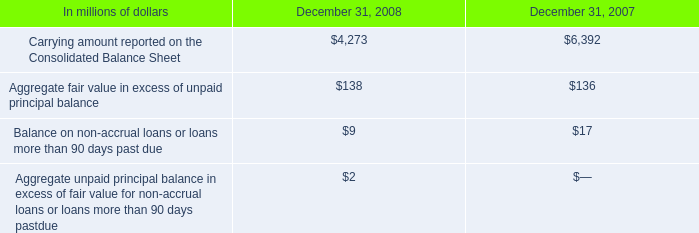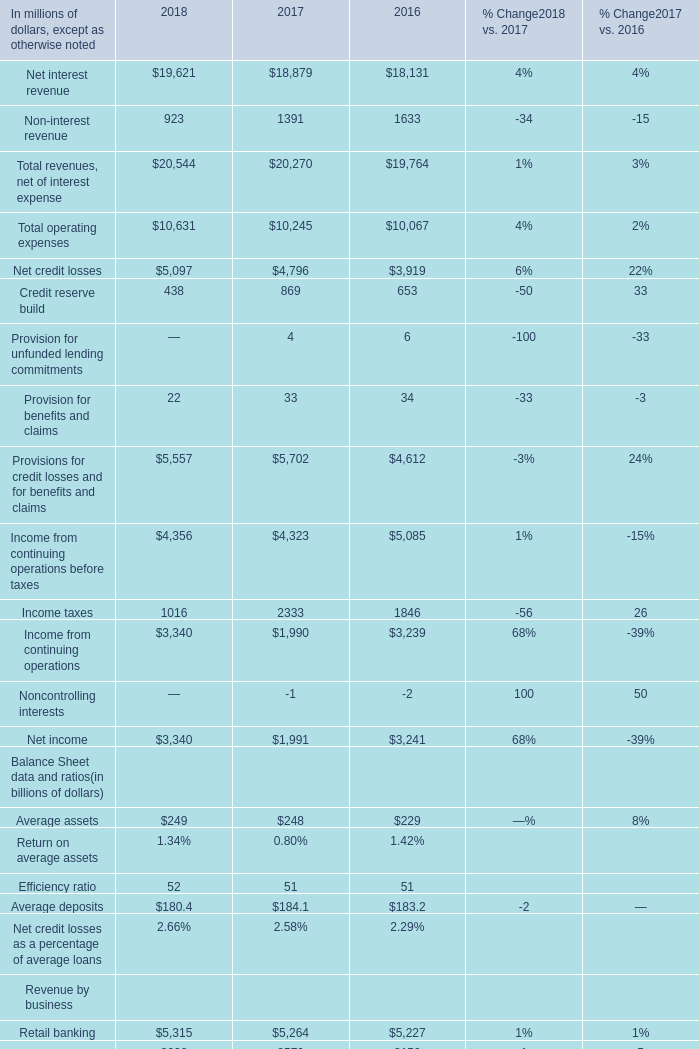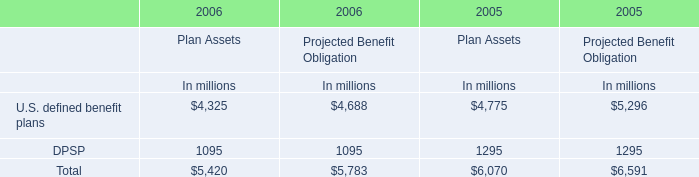what was the percentage change in the carrying amount reported on the consolidated balance sheet from 2007 to 2008? 
Computations: ((4273 - 6392) / 6392)
Answer: -0.33151. 